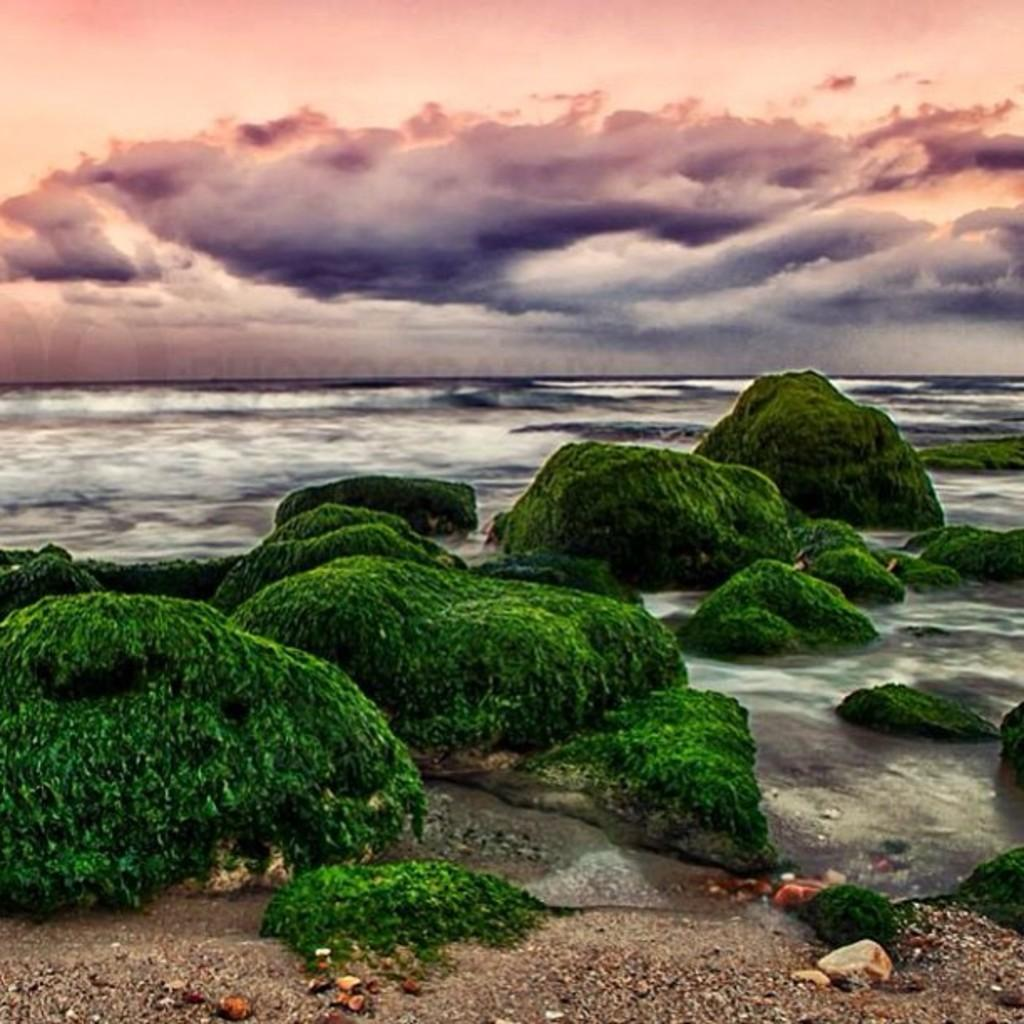What type of vegetation is present on the water in the image? There are mosses on the water in the image. What part of the natural environment is visible in the image? The sky is visible at the top side of the image. Can you see an owl sitting on the mosses in the image? There is no owl present in the image; it only features mosses on the water and the sky. Is there a badge visible on the water in the image? There is no badge present in the image; it only features mosses on the water and the sky. 